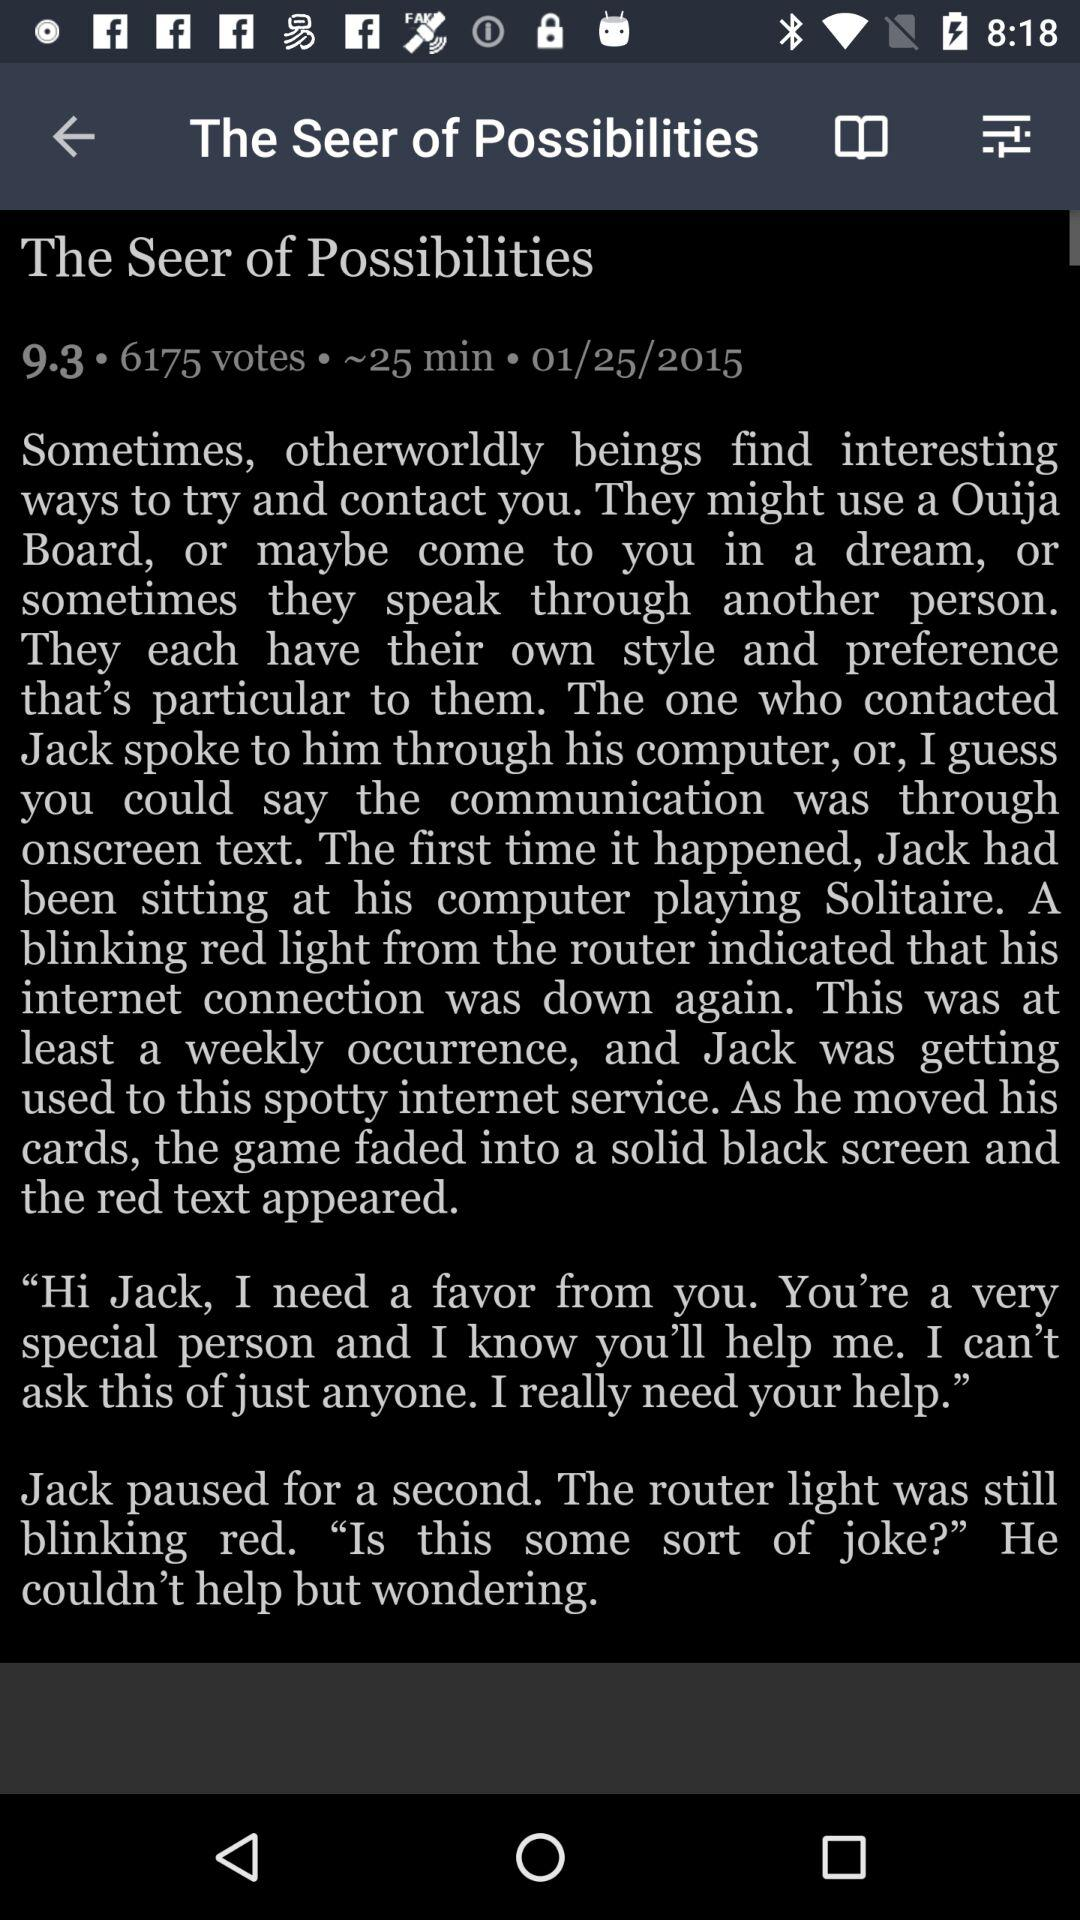What's the total number of votes? The total number of votes is 6175. 